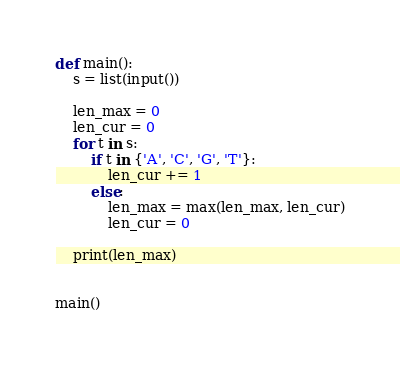<code> <loc_0><loc_0><loc_500><loc_500><_Python_>def main():
    s = list(input())

    len_max = 0
    len_cur = 0
    for t in s:
        if t in {'A', 'C', 'G', 'T'}:
            len_cur += 1
        else:
            len_max = max(len_max, len_cur)
            len_cur = 0

    print(len_max)


main()
</code> 